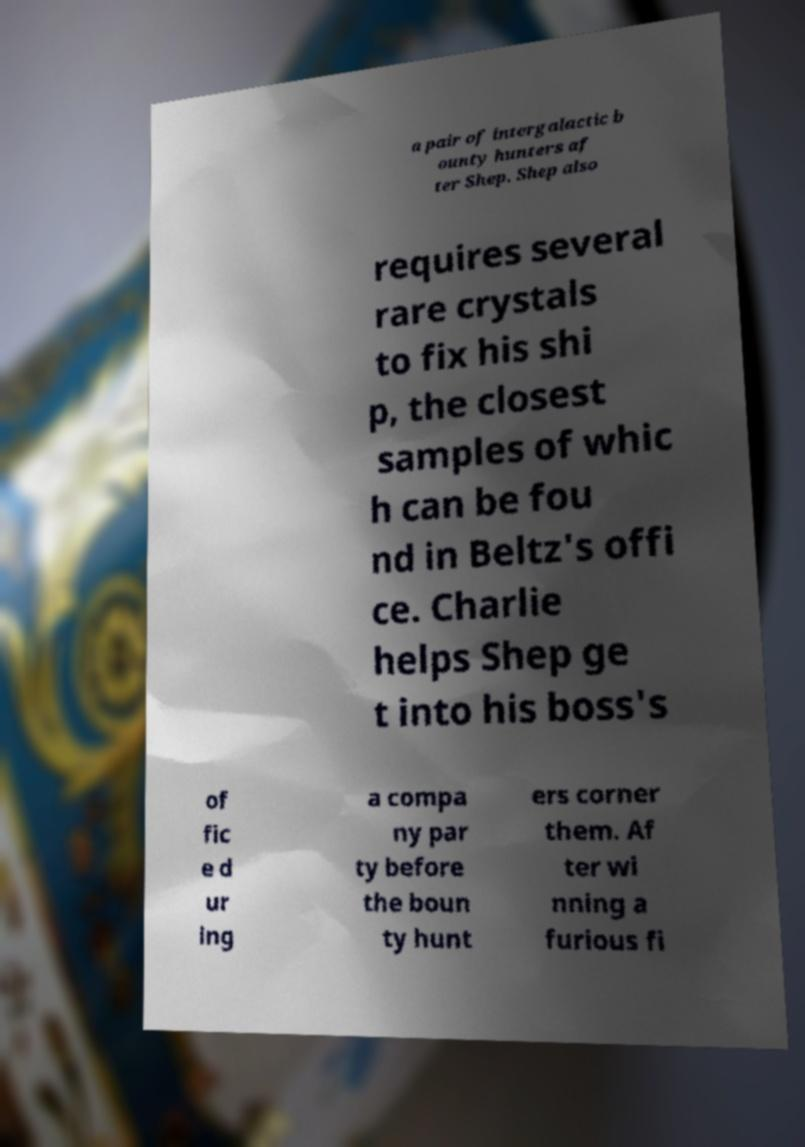Could you extract and type out the text from this image? a pair of intergalactic b ounty hunters af ter Shep. Shep also requires several rare crystals to fix his shi p, the closest samples of whic h can be fou nd in Beltz's offi ce. Charlie helps Shep ge t into his boss's of fic e d ur ing a compa ny par ty before the boun ty hunt ers corner them. Af ter wi nning a furious fi 